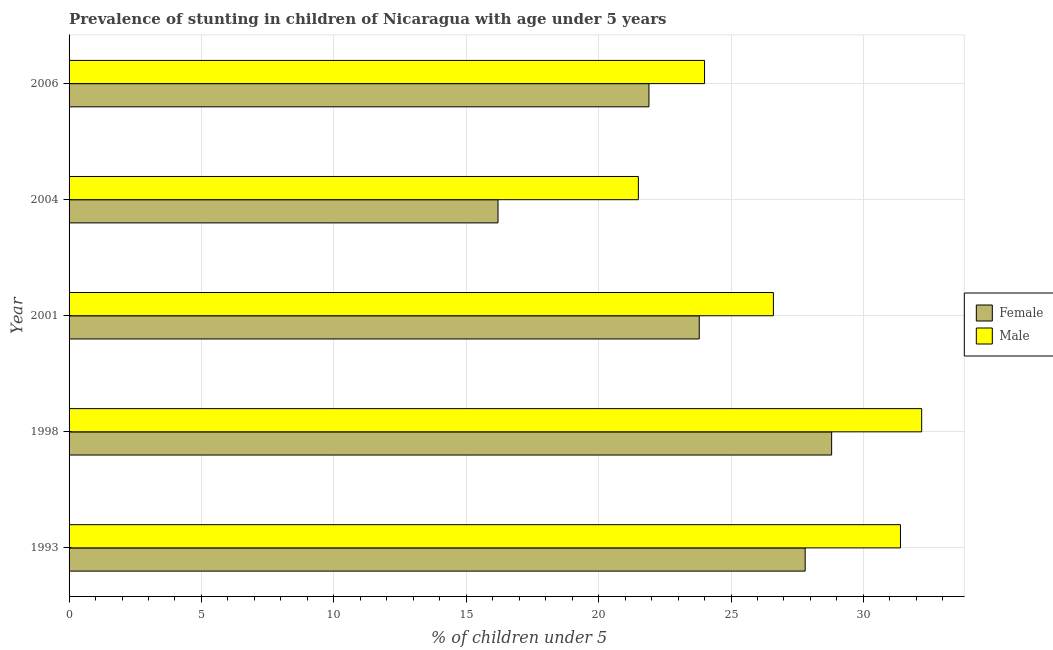Are the number of bars per tick equal to the number of legend labels?
Make the answer very short. Yes. Are the number of bars on each tick of the Y-axis equal?
Offer a very short reply. Yes. How many bars are there on the 2nd tick from the top?
Keep it short and to the point. 2. How many bars are there on the 5th tick from the bottom?
Your answer should be very brief. 2. What is the label of the 5th group of bars from the top?
Give a very brief answer. 1993. In how many cases, is the number of bars for a given year not equal to the number of legend labels?
Keep it short and to the point. 0. Across all years, what is the maximum percentage of stunted female children?
Your response must be concise. 28.8. Across all years, what is the minimum percentage of stunted female children?
Make the answer very short. 16.2. In which year was the percentage of stunted male children minimum?
Make the answer very short. 2004. What is the total percentage of stunted male children in the graph?
Provide a succinct answer. 135.7. What is the difference between the percentage of stunted male children in 1993 and that in 2006?
Your response must be concise. 7.4. What is the difference between the percentage of stunted male children in 2006 and the percentage of stunted female children in 2004?
Your answer should be compact. 7.8. What is the average percentage of stunted male children per year?
Ensure brevity in your answer.  27.14. In the year 1998, what is the difference between the percentage of stunted male children and percentage of stunted female children?
Ensure brevity in your answer.  3.4. Is the percentage of stunted female children in 2001 less than that in 2004?
Make the answer very short. No. Is the difference between the percentage of stunted male children in 1993 and 2006 greater than the difference between the percentage of stunted female children in 1993 and 2006?
Ensure brevity in your answer.  Yes. Are all the bars in the graph horizontal?
Keep it short and to the point. Yes. How many years are there in the graph?
Keep it short and to the point. 5. Are the values on the major ticks of X-axis written in scientific E-notation?
Make the answer very short. No. Does the graph contain any zero values?
Offer a terse response. No. Does the graph contain grids?
Keep it short and to the point. Yes. How are the legend labels stacked?
Provide a succinct answer. Vertical. What is the title of the graph?
Give a very brief answer. Prevalence of stunting in children of Nicaragua with age under 5 years. Does "Merchandise exports" appear as one of the legend labels in the graph?
Ensure brevity in your answer.  No. What is the label or title of the X-axis?
Give a very brief answer.  % of children under 5. What is the  % of children under 5 in Female in 1993?
Give a very brief answer. 27.8. What is the  % of children under 5 of Male in 1993?
Provide a short and direct response. 31.4. What is the  % of children under 5 in Female in 1998?
Ensure brevity in your answer.  28.8. What is the  % of children under 5 in Male in 1998?
Ensure brevity in your answer.  32.2. What is the  % of children under 5 of Female in 2001?
Your answer should be very brief. 23.8. What is the  % of children under 5 in Male in 2001?
Provide a succinct answer. 26.6. What is the  % of children under 5 of Female in 2004?
Provide a short and direct response. 16.2. What is the  % of children under 5 in Male in 2004?
Your answer should be compact. 21.5. What is the  % of children under 5 in Female in 2006?
Ensure brevity in your answer.  21.9. Across all years, what is the maximum  % of children under 5 of Female?
Provide a succinct answer. 28.8. Across all years, what is the maximum  % of children under 5 of Male?
Your answer should be very brief. 32.2. Across all years, what is the minimum  % of children under 5 of Female?
Your answer should be very brief. 16.2. What is the total  % of children under 5 of Female in the graph?
Give a very brief answer. 118.5. What is the total  % of children under 5 of Male in the graph?
Your answer should be compact. 135.7. What is the difference between the  % of children under 5 in Female in 1993 and that in 1998?
Offer a very short reply. -1. What is the difference between the  % of children under 5 of Female in 1993 and that in 2001?
Keep it short and to the point. 4. What is the difference between the  % of children under 5 in Male in 1993 and that in 2001?
Give a very brief answer. 4.8. What is the difference between the  % of children under 5 of Male in 1993 and that in 2006?
Offer a terse response. 7.4. What is the difference between the  % of children under 5 in Female in 1998 and that in 2006?
Provide a succinct answer. 6.9. What is the difference between the  % of children under 5 in Male in 1998 and that in 2006?
Provide a succinct answer. 8.2. What is the difference between the  % of children under 5 in Female in 2001 and that in 2004?
Offer a terse response. 7.6. What is the difference between the  % of children under 5 in Male in 2001 and that in 2006?
Your answer should be very brief. 2.6. What is the difference between the  % of children under 5 of Female in 2004 and that in 2006?
Your response must be concise. -5.7. What is the difference between the  % of children under 5 in Female in 1993 and the  % of children under 5 in Male in 1998?
Keep it short and to the point. -4.4. What is the difference between the  % of children under 5 in Female in 1993 and the  % of children under 5 in Male in 2006?
Your answer should be very brief. 3.8. What is the difference between the  % of children under 5 of Female in 1998 and the  % of children under 5 of Male in 2004?
Ensure brevity in your answer.  7.3. What is the difference between the  % of children under 5 in Female in 1998 and the  % of children under 5 in Male in 2006?
Your answer should be very brief. 4.8. What is the difference between the  % of children under 5 in Female in 2001 and the  % of children under 5 in Male in 2004?
Provide a succinct answer. 2.3. What is the difference between the  % of children under 5 in Female in 2004 and the  % of children under 5 in Male in 2006?
Provide a short and direct response. -7.8. What is the average  % of children under 5 in Female per year?
Your answer should be compact. 23.7. What is the average  % of children under 5 of Male per year?
Offer a very short reply. 27.14. In the year 2004, what is the difference between the  % of children under 5 of Female and  % of children under 5 of Male?
Give a very brief answer. -5.3. In the year 2006, what is the difference between the  % of children under 5 of Female and  % of children under 5 of Male?
Offer a very short reply. -2.1. What is the ratio of the  % of children under 5 in Female in 1993 to that in 1998?
Your answer should be compact. 0.97. What is the ratio of the  % of children under 5 in Male in 1993 to that in 1998?
Your answer should be very brief. 0.98. What is the ratio of the  % of children under 5 of Female in 1993 to that in 2001?
Provide a succinct answer. 1.17. What is the ratio of the  % of children under 5 of Male in 1993 to that in 2001?
Provide a succinct answer. 1.18. What is the ratio of the  % of children under 5 in Female in 1993 to that in 2004?
Keep it short and to the point. 1.72. What is the ratio of the  % of children under 5 of Male in 1993 to that in 2004?
Offer a terse response. 1.46. What is the ratio of the  % of children under 5 in Female in 1993 to that in 2006?
Your answer should be compact. 1.27. What is the ratio of the  % of children under 5 in Male in 1993 to that in 2006?
Give a very brief answer. 1.31. What is the ratio of the  % of children under 5 in Female in 1998 to that in 2001?
Offer a very short reply. 1.21. What is the ratio of the  % of children under 5 of Male in 1998 to that in 2001?
Offer a terse response. 1.21. What is the ratio of the  % of children under 5 in Female in 1998 to that in 2004?
Keep it short and to the point. 1.78. What is the ratio of the  % of children under 5 in Male in 1998 to that in 2004?
Keep it short and to the point. 1.5. What is the ratio of the  % of children under 5 in Female in 1998 to that in 2006?
Provide a succinct answer. 1.32. What is the ratio of the  % of children under 5 in Male in 1998 to that in 2006?
Ensure brevity in your answer.  1.34. What is the ratio of the  % of children under 5 in Female in 2001 to that in 2004?
Offer a terse response. 1.47. What is the ratio of the  % of children under 5 of Male in 2001 to that in 2004?
Give a very brief answer. 1.24. What is the ratio of the  % of children under 5 in Female in 2001 to that in 2006?
Your answer should be very brief. 1.09. What is the ratio of the  % of children under 5 in Male in 2001 to that in 2006?
Ensure brevity in your answer.  1.11. What is the ratio of the  % of children under 5 in Female in 2004 to that in 2006?
Your response must be concise. 0.74. What is the ratio of the  % of children under 5 of Male in 2004 to that in 2006?
Your answer should be compact. 0.9. What is the difference between the highest and the second highest  % of children under 5 in Female?
Your answer should be very brief. 1. What is the difference between the highest and the second highest  % of children under 5 of Male?
Offer a very short reply. 0.8. What is the difference between the highest and the lowest  % of children under 5 in Male?
Your response must be concise. 10.7. 